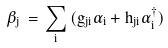<formula> <loc_0><loc_0><loc_500><loc_500>\beta _ { j } \, = \, \sum _ { i } \, ( g _ { j i } \alpha _ { i } + h _ { j i } \alpha _ { i } ^ { \dagger } )</formula> 